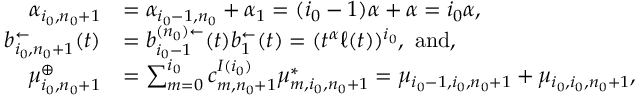Convert formula to latex. <formula><loc_0><loc_0><loc_500><loc_500>\begin{array} { r l } { \alpha _ { i _ { 0 } , n _ { 0 } + 1 } } & { = \alpha _ { i _ { 0 } - 1 , n _ { 0 } } + \alpha _ { 1 } = ( i _ { 0 } - 1 ) \alpha + \alpha = i _ { 0 } \alpha , } \\ { { b } _ { i _ { 0 } , n _ { 0 } + 1 } ^ { \leftarrow } ( t ) } & { = b _ { i _ { 0 } - 1 } ^ { ( n _ { 0 } ) \leftarrow } ( t ) b _ { 1 } ^ { \leftarrow } ( t ) = ( t ^ { \alpha } \ell ( t ) ) ^ { i _ { 0 } } , a n d , } \\ { \mu _ { i _ { 0 } , n _ { 0 } + 1 } ^ { \oplus } } & { = \sum _ { m = 0 } ^ { i _ { 0 } } c _ { m , n _ { 0 } + 1 } ^ { I ( i _ { 0 } ) } \mu _ { m , i _ { 0 } , n _ { 0 } + 1 } ^ { * } = \mu _ { i _ { 0 } - 1 , i _ { 0 } , n _ { 0 } + 1 } + \mu _ { i _ { 0 } , i _ { 0 } , n _ { 0 } + 1 } , } \end{array}</formula> 